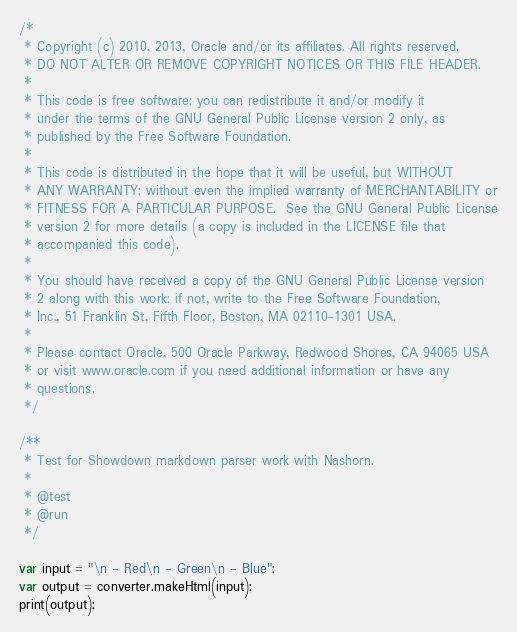Convert code to text. <code><loc_0><loc_0><loc_500><loc_500><_JavaScript_>/*
 * Copyright (c) 2010, 2013, Oracle and/or its affiliates. All rights reserved.
 * DO NOT ALTER OR REMOVE COPYRIGHT NOTICES OR THIS FILE HEADER.
 *
 * This code is free software; you can redistribute it and/or modify it
 * under the terms of the GNU General Public License version 2 only, as
 * published by the Free Software Foundation.
 *
 * This code is distributed in the hope that it will be useful, but WITHOUT
 * ANY WARRANTY; without even the implied warranty of MERCHANTABILITY or
 * FITNESS FOR A PARTICULAR PURPOSE.  See the GNU General Public License
 * version 2 for more details (a copy is included in the LICENSE file that
 * accompanied this code).
 *
 * You should have received a copy of the GNU General Public License version
 * 2 along with this work; if not, write to the Free Software Foundation,
 * Inc., 51 Franklin St, Fifth Floor, Boston, MA 02110-1301 USA.
 *
 * Please contact Oracle, 500 Oracle Parkway, Redwood Shores, CA 94065 USA
 * or visit www.oracle.com if you need additional information or have any
 * questions.
 */

/**
 * Test for Showdown markdown parser work with Nashorn.
 *
 * @test
 * @run
 */

var input = "\n - Red\n - Green\n - Blue";
var output = converter.makeHtml(input);
print(output);
</code> 